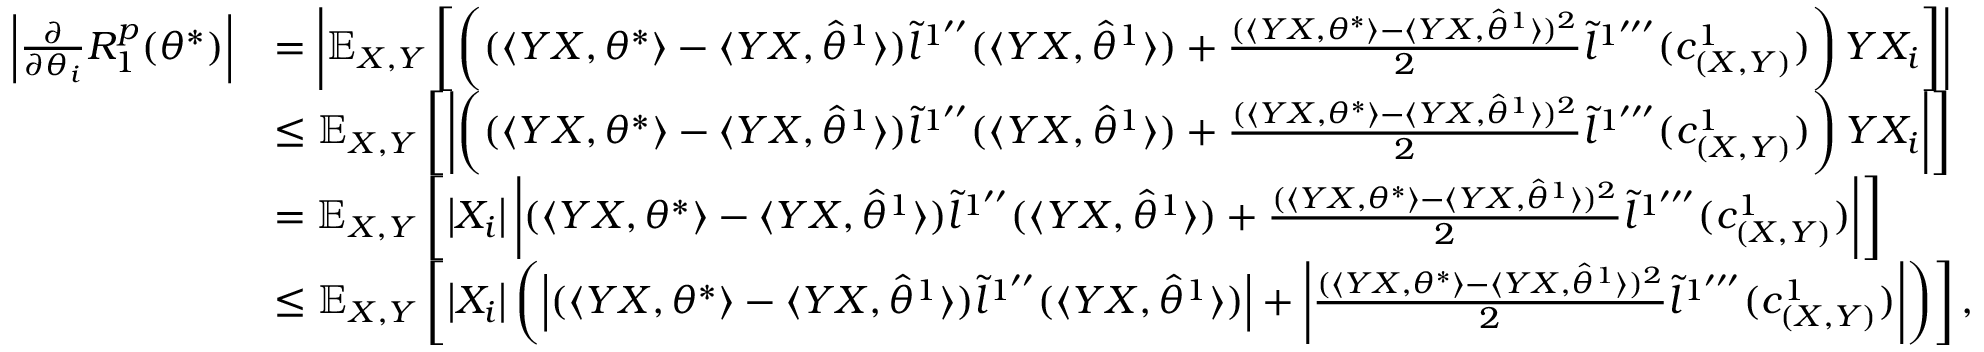<formula> <loc_0><loc_0><loc_500><loc_500>\begin{array} { r l } { \left | \frac { \partial } { \partial \theta _ { i } } R _ { 1 } ^ { p } ( \theta ^ { * } ) \right | } & { = \left | \mathbb { E } _ { X , Y } \left [ \left ( ( \langle Y X , \theta ^ { * } \rangle - \langle Y X , \hat { \theta } ^ { 1 } \rangle ) \tilde { l } ^ { 1 ^ { \prime \prime } } ( \langle Y X , \hat { \theta } ^ { 1 } \rangle ) + \frac { ( \langle Y X , \theta ^ { * } \rangle - \langle Y X , \hat { \theta } ^ { 1 } \rangle ) ^ { 2 } } { 2 } \tilde { l } ^ { 1 ^ { \prime \prime \prime } } ( c _ { ( X , Y ) } ^ { 1 } ) \right ) Y X _ { i } \right ] \right | } \\ & { \leq \mathbb { E } _ { X , Y } \left [ \left | \left ( ( \langle Y X , \theta ^ { * } \rangle - \langle Y X , \hat { \theta } ^ { 1 } \rangle ) \tilde { l } ^ { 1 ^ { \prime \prime } } ( \langle Y X , \hat { \theta } ^ { 1 } \rangle ) + \frac { ( \langle Y X , \theta ^ { * } \rangle - \langle Y X , \hat { \theta } ^ { 1 } \rangle ) ^ { 2 } } { 2 } \tilde { l } ^ { 1 ^ { \prime \prime \prime } } ( c _ { ( X , Y ) } ^ { 1 } ) \right ) Y X _ { i } \right | \right ] } \\ & { = \mathbb { E } _ { X , Y } \left [ \left | X _ { i } \right | \left | ( \langle Y X , \theta ^ { * } \rangle - \langle Y X , \hat { \theta } ^ { 1 } \rangle ) \tilde { l } ^ { 1 ^ { \prime \prime } } ( \langle Y X , \hat { \theta } ^ { 1 } \rangle ) + \frac { ( \langle Y X , \theta ^ { * } \rangle - \langle Y X , \hat { \theta } ^ { 1 } \rangle ) ^ { 2 } } { 2 } \tilde { l } ^ { 1 ^ { \prime \prime \prime } } ( c _ { ( X , Y ) } ^ { 1 } ) \right | \right ] } \\ & { \leq \mathbb { E } _ { X , Y } \left [ \left | X _ { i } \right | \left ( \left | ( \langle Y X , \theta ^ { * } \rangle - \langle Y X , \hat { \theta } ^ { 1 } \rangle ) \tilde { l } ^ { 1 ^ { \prime \prime } } ( \langle Y X , \hat { \theta } ^ { 1 } \rangle ) \right | + \left | \frac { ( \langle Y X , \theta ^ { * } \rangle - \langle Y X , \hat { \theta } ^ { 1 } \rangle ) ^ { 2 } } { 2 } \tilde { l } ^ { 1 ^ { \prime \prime \prime } } ( c _ { ( X , Y ) } ^ { 1 } ) \right | \right ) \right ] , } \end{array}</formula> 